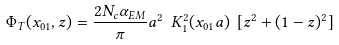Convert formula to latex. <formula><loc_0><loc_0><loc_500><loc_500>\Phi _ { T } ( { x } _ { 0 1 } , z ) = \frac { 2 N _ { c } \alpha _ { E M } } { \pi } a ^ { 2 } \ K _ { 1 } ^ { 2 } ( x _ { 0 1 } a ) \ [ z ^ { 2 } + ( 1 - z ) ^ { 2 } ]</formula> 